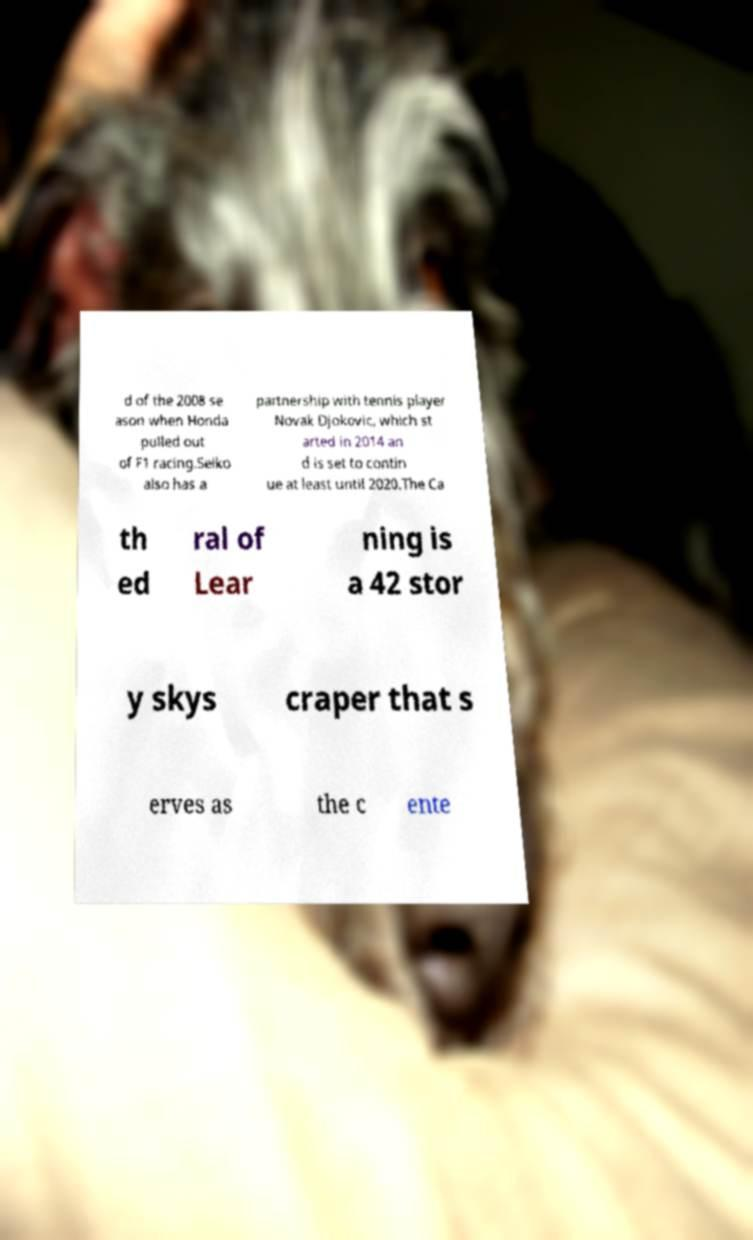Could you extract and type out the text from this image? d of the 2008 se ason when Honda pulled out of F1 racing.Seiko also has a partnership with tennis player Novak Djokovic, which st arted in 2014 an d is set to contin ue at least until 2020.The Ca th ed ral of Lear ning is a 42 stor y skys craper that s erves as the c ente 